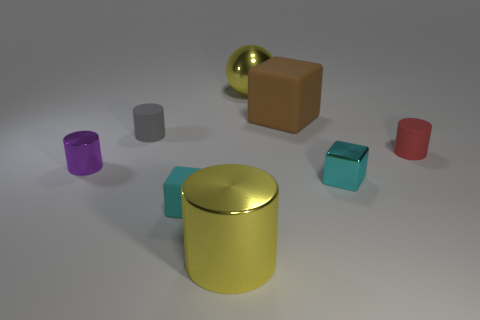Subtract all tiny cylinders. How many cylinders are left? 1 Add 2 cylinders. How many objects exist? 10 Subtract 1 blocks. How many blocks are left? 2 Subtract all yellow cylinders. How many cylinders are left? 3 Subtract all purple spheres. How many gray cylinders are left? 1 Add 1 big yellow cylinders. How many big yellow cylinders are left? 2 Add 7 small gray matte balls. How many small gray matte balls exist? 7 Subtract 0 purple blocks. How many objects are left? 8 Subtract all blocks. How many objects are left? 5 Subtract all blue spheres. Subtract all cyan cubes. How many spheres are left? 1 